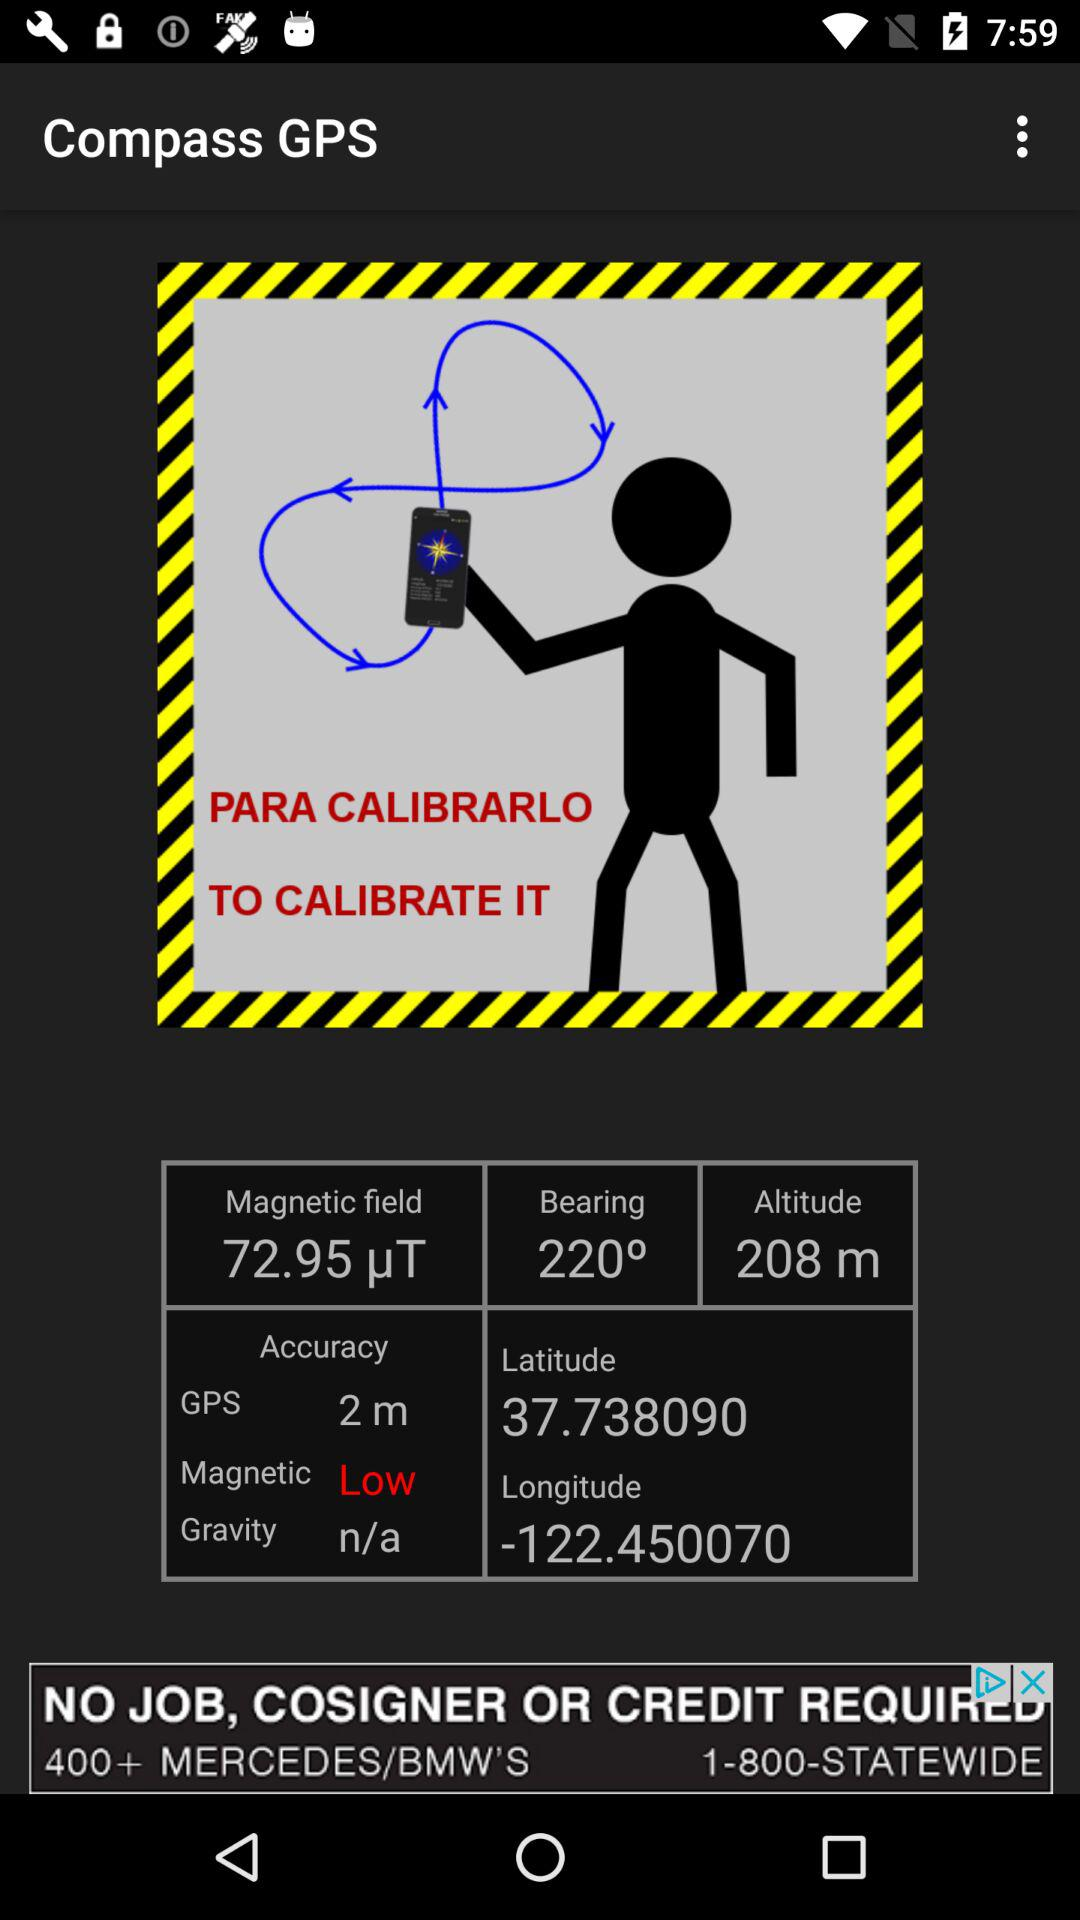What is the latitude? The latitude is 37.738099. 